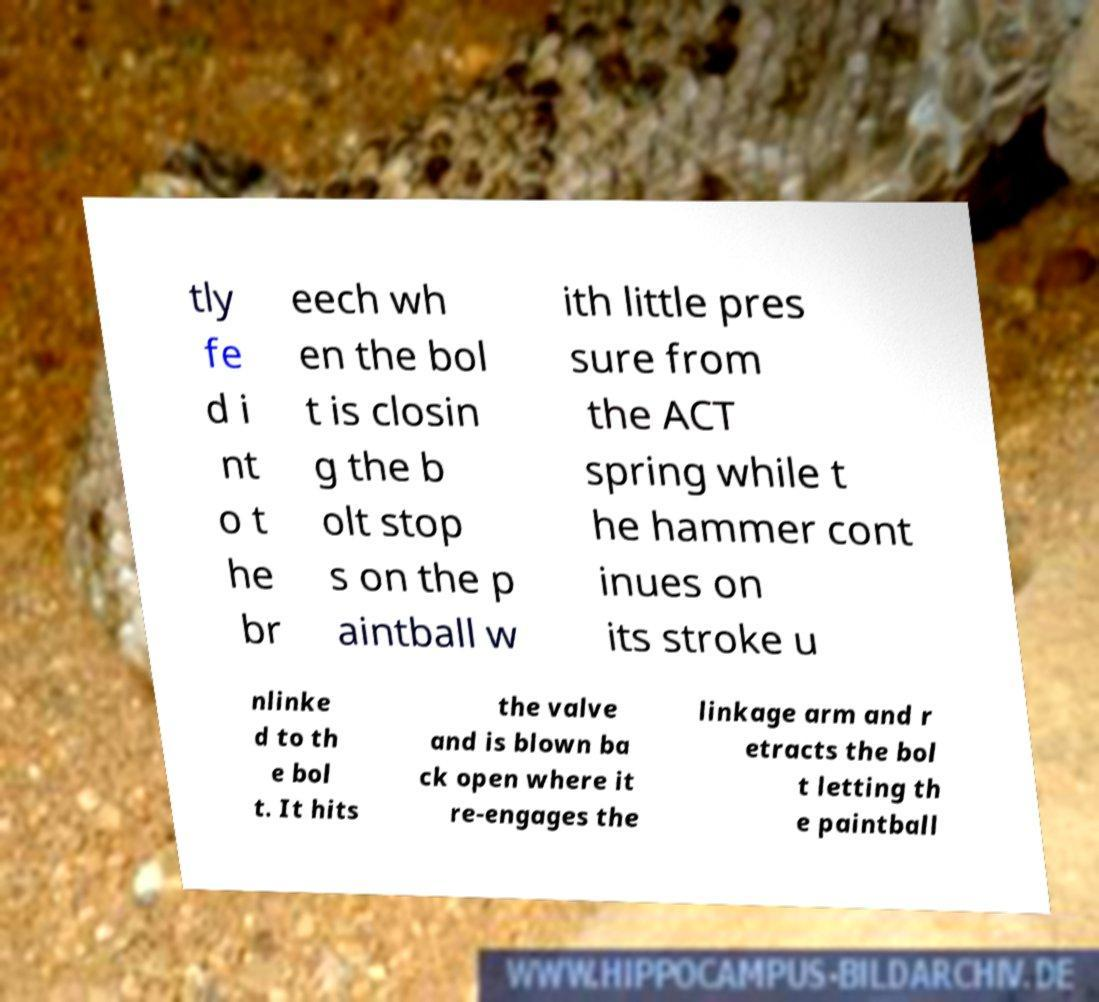Please read and relay the text visible in this image. What does it say? tly fe d i nt o t he br eech wh en the bol t is closin g the b olt stop s on the p aintball w ith little pres sure from the ACT spring while t he hammer cont inues on its stroke u nlinke d to th e bol t. It hits the valve and is blown ba ck open where it re-engages the linkage arm and r etracts the bol t letting th e paintball 